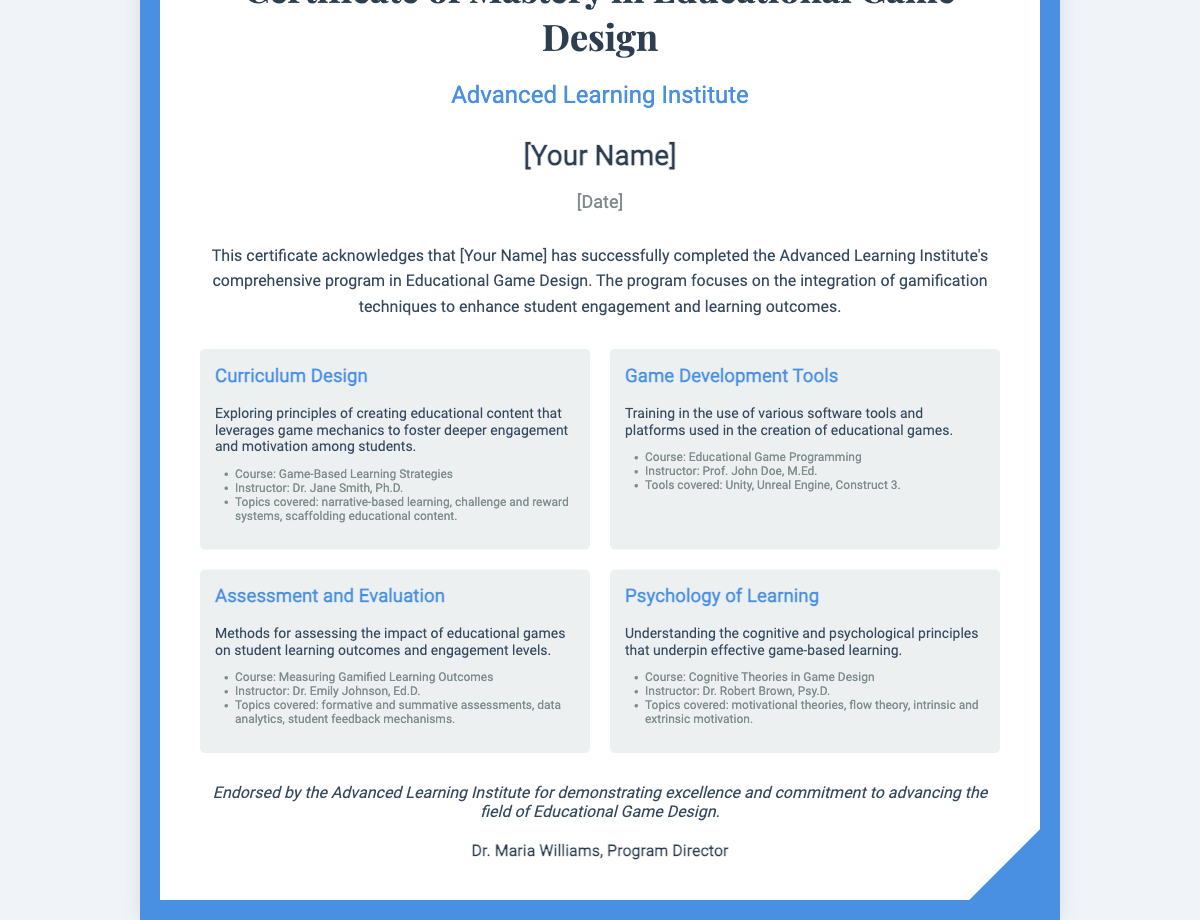What is the title of the certificate? The title of the certificate is prominently displayed at the top of the document, which is "Certificate of Mastery in Educational Game Design."
Answer: Certificate of Mastery in Educational Game Design Who is the issuing institution? The issuing institution is listed just below the title, which is "Advanced Learning Institute."
Answer: Advanced Learning Institute What is the student's name placeholder? The document contains a placeholder for the student's name, indicating where the actual name will be placed.
Answer: [Your Name] What is the completion date placeholder? The document includes a placeholder for the completion date, where the actual date will be entered.
Answer: [Date] What course is associated with Curriculum Design? The course associated with Curriculum Design is mentioned in the respective component, indicating the specific focus of that part of the curriculum.
Answer: Game-Based Learning Strategies Who teaches the Game Development Tools course? The instructor for the Game Development Tools course is provided within the component detailing this area of study.
Answer: Prof. John Doe, M.Ed What is one of the instruments covered in the Game Development Tools course? Specific tools used in the Game Development Tools course are outlined, indicating practical applications for students.
Answer: Unity What is the main focus of the Assessment and Evaluation component? This component describes the general emphasis of assessing educational game impacts on student outcomes.
Answer: Impact of educational games on student learning outcomes Who endorsed the certificate? The endorsement demonstrates recognition for the efforts and achievements within the program, attributed to a specific individual.
Answer: Dr. Maria Williams, Program Director 